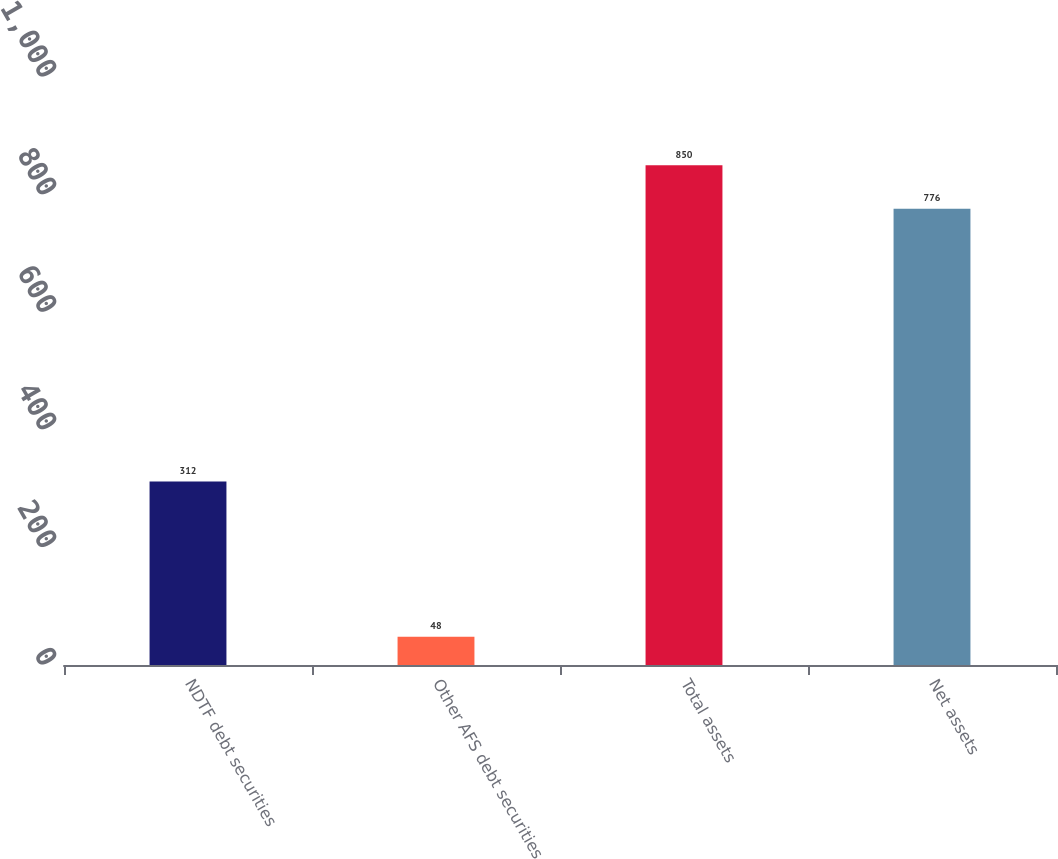Convert chart to OTSL. <chart><loc_0><loc_0><loc_500><loc_500><bar_chart><fcel>NDTF debt securities<fcel>Other AFS debt securities<fcel>Total assets<fcel>Net assets<nl><fcel>312<fcel>48<fcel>850<fcel>776<nl></chart> 